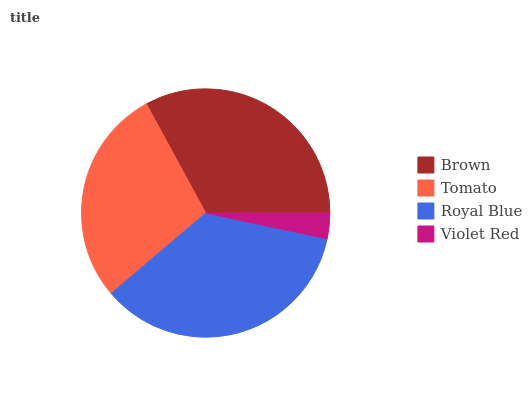Is Violet Red the minimum?
Answer yes or no. Yes. Is Royal Blue the maximum?
Answer yes or no. Yes. Is Tomato the minimum?
Answer yes or no. No. Is Tomato the maximum?
Answer yes or no. No. Is Brown greater than Tomato?
Answer yes or no. Yes. Is Tomato less than Brown?
Answer yes or no. Yes. Is Tomato greater than Brown?
Answer yes or no. No. Is Brown less than Tomato?
Answer yes or no. No. Is Brown the high median?
Answer yes or no. Yes. Is Tomato the low median?
Answer yes or no. Yes. Is Royal Blue the high median?
Answer yes or no. No. Is Brown the low median?
Answer yes or no. No. 